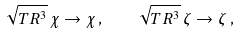<formula> <loc_0><loc_0><loc_500><loc_500>\sqrt { T R ^ { 3 } } \, \chi \to \chi \, , \quad \sqrt { T R ^ { 3 } } \, \zeta \to \zeta \, ,</formula> 